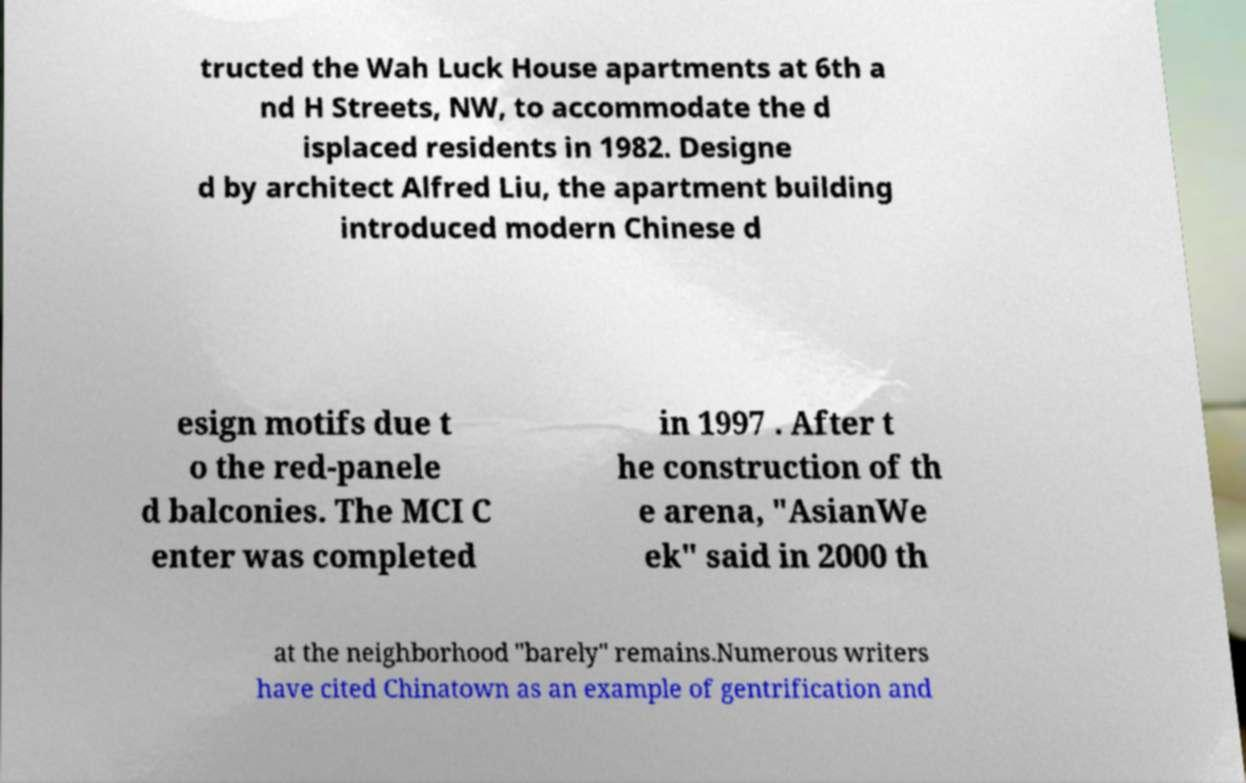There's text embedded in this image that I need extracted. Can you transcribe it verbatim? tructed the Wah Luck House apartments at 6th a nd H Streets, NW, to accommodate the d isplaced residents in 1982. Designe d by architect Alfred Liu, the apartment building introduced modern Chinese d esign motifs due t o the red-panele d balconies. The MCI C enter was completed in 1997 . After t he construction of th e arena, "AsianWe ek" said in 2000 th at the neighborhood "barely" remains.Numerous writers have cited Chinatown as an example of gentrification and 